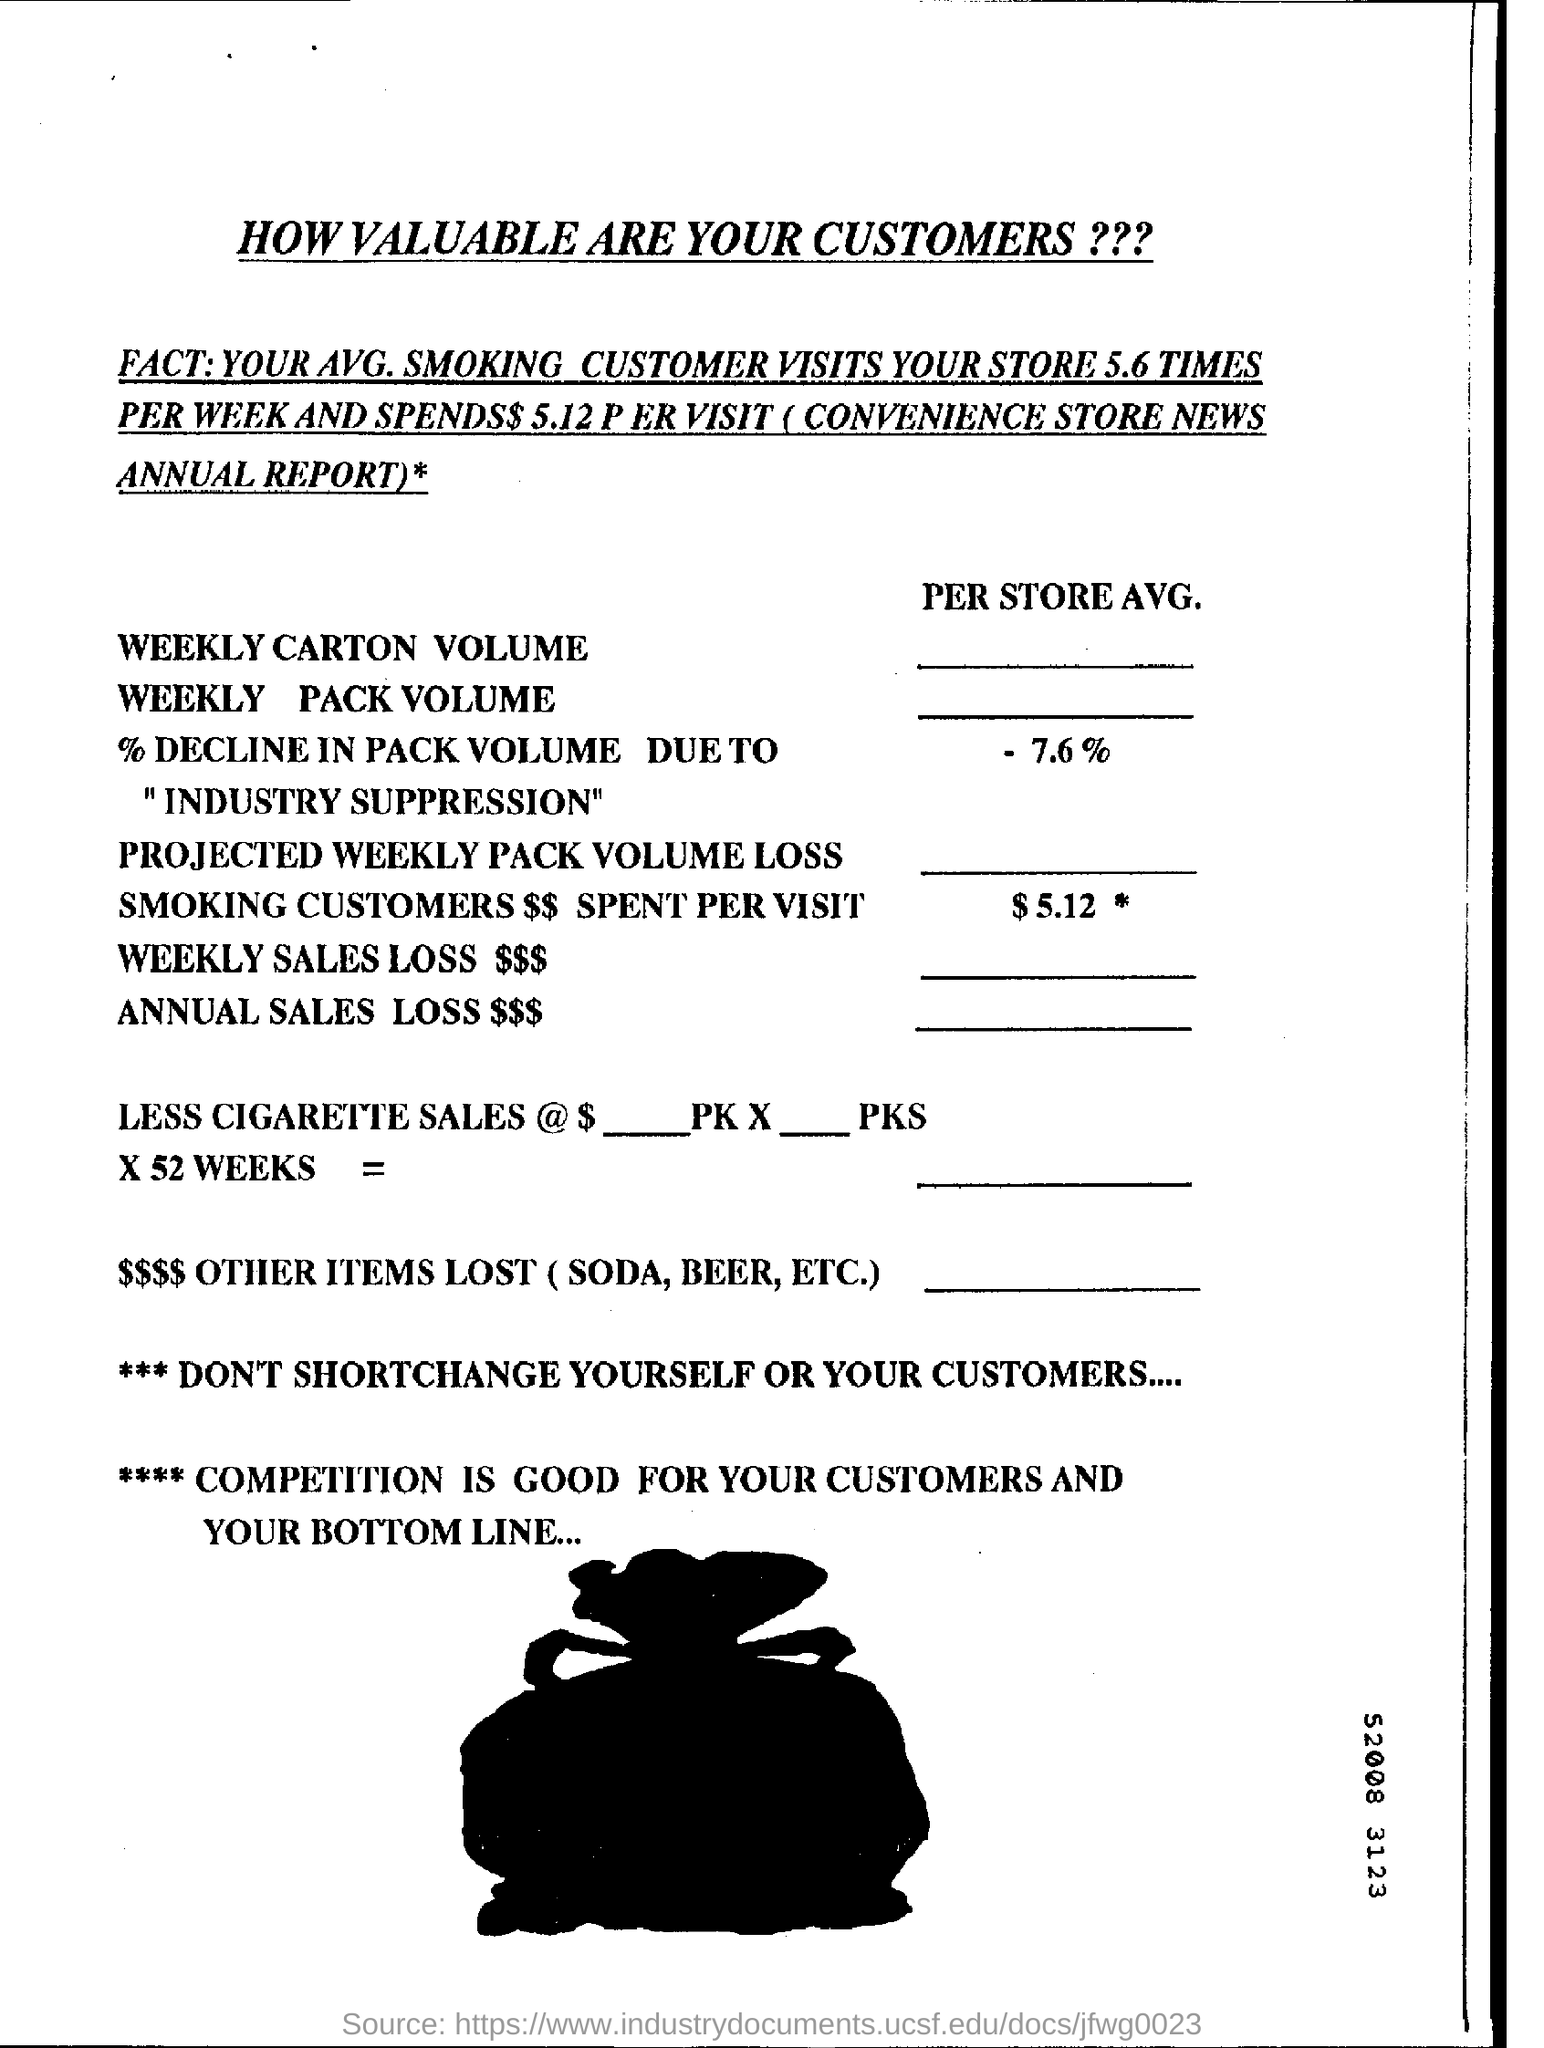Indicate a few pertinent items in this graphic. The decline in pack volume due to industry suppression was -7.6%. Our data suggests that smokers are likely to spend an average of $5.12 per visit, with a projected weekly pack volume loss. 